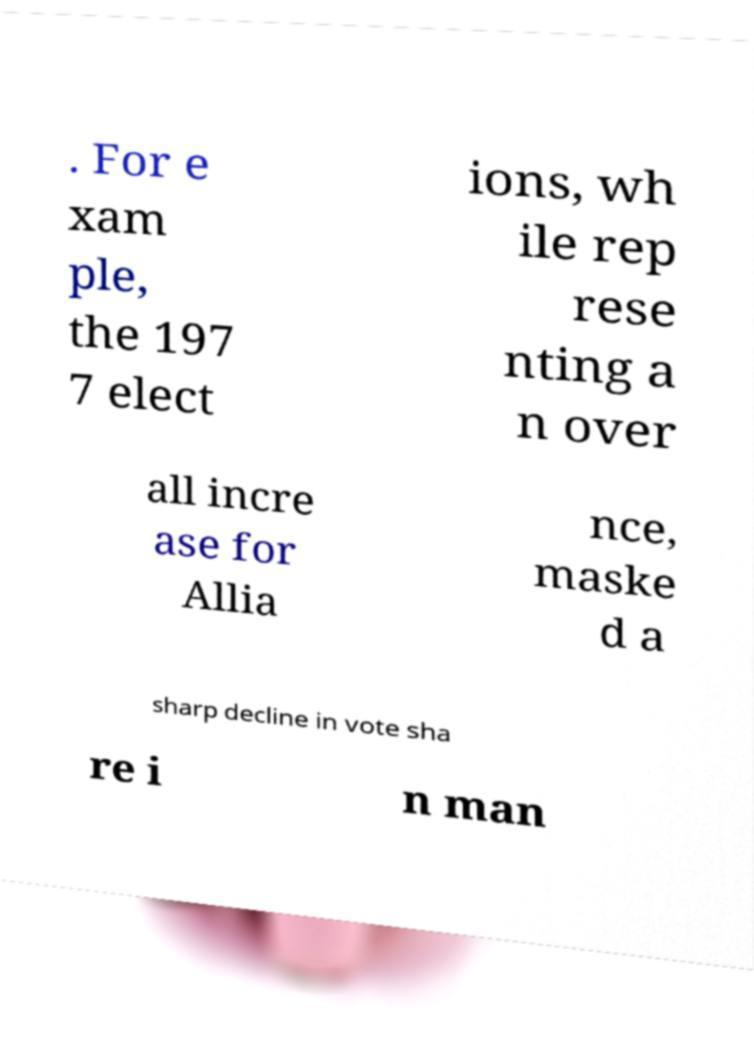For documentation purposes, I need the text within this image transcribed. Could you provide that? . For e xam ple, the 197 7 elect ions, wh ile rep rese nting a n over all incre ase for Allia nce, maske d a sharp decline in vote sha re i n man 